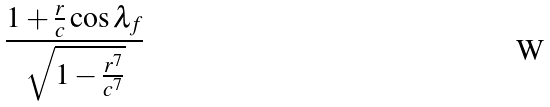<formula> <loc_0><loc_0><loc_500><loc_500>\frac { 1 + \frac { r } { c } \cos \lambda _ { f } } { \sqrt { 1 - \frac { r ^ { 7 } } { c ^ { 7 } } } }</formula> 